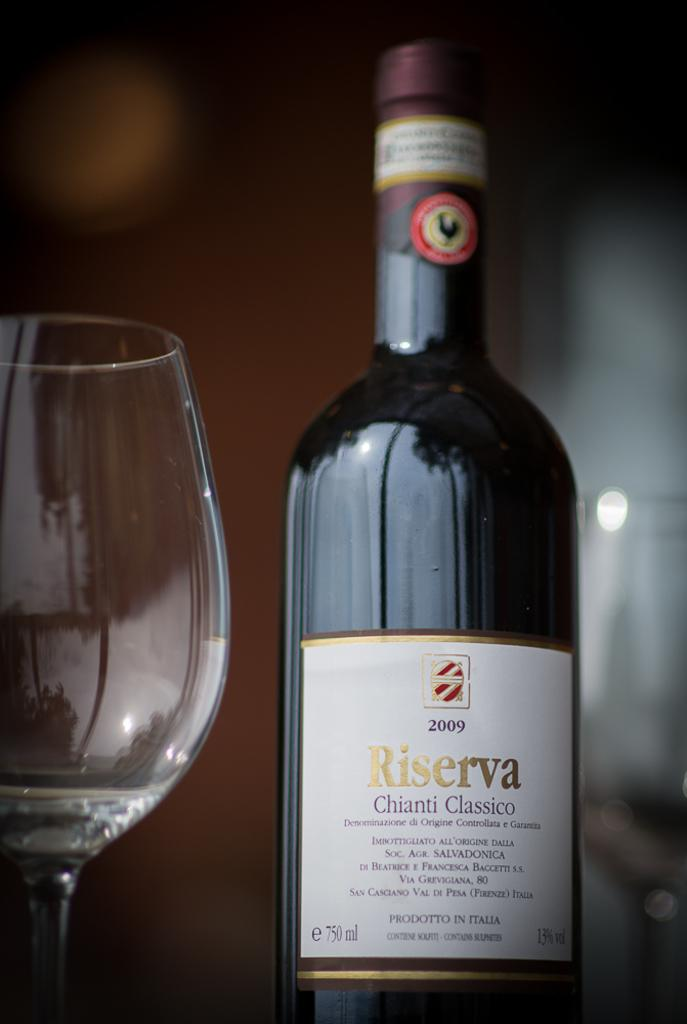<image>
Relay a brief, clear account of the picture shown. A bottle of red wine next to a glass, the wine is Riserva Chianti Classico 